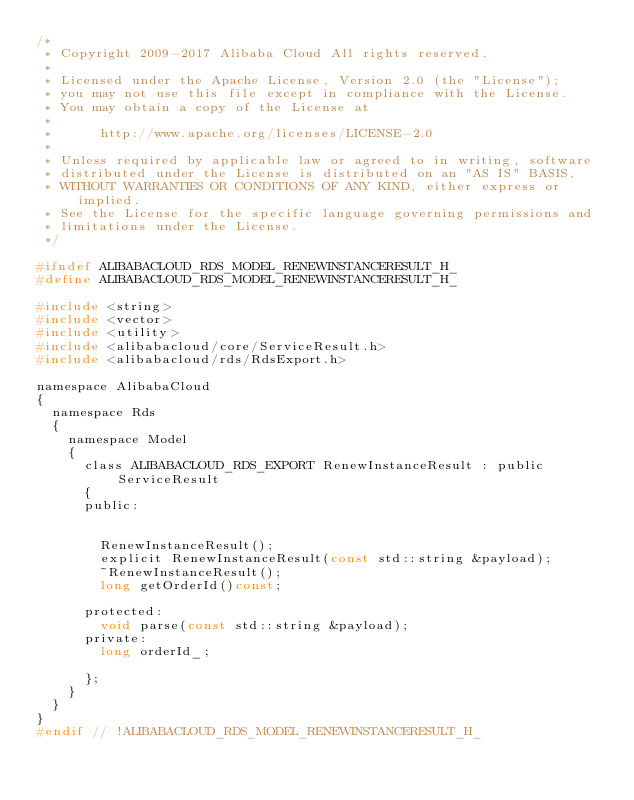<code> <loc_0><loc_0><loc_500><loc_500><_C_>/*
 * Copyright 2009-2017 Alibaba Cloud All rights reserved.
 * 
 * Licensed under the Apache License, Version 2.0 (the "License");
 * you may not use this file except in compliance with the License.
 * You may obtain a copy of the License at
 * 
 *      http://www.apache.org/licenses/LICENSE-2.0
 * 
 * Unless required by applicable law or agreed to in writing, software
 * distributed under the License is distributed on an "AS IS" BASIS,
 * WITHOUT WARRANTIES OR CONDITIONS OF ANY KIND, either express or implied.
 * See the License for the specific language governing permissions and
 * limitations under the License.
 */

#ifndef ALIBABACLOUD_RDS_MODEL_RENEWINSTANCERESULT_H_
#define ALIBABACLOUD_RDS_MODEL_RENEWINSTANCERESULT_H_

#include <string>
#include <vector>
#include <utility>
#include <alibabacloud/core/ServiceResult.h>
#include <alibabacloud/rds/RdsExport.h>

namespace AlibabaCloud
{
	namespace Rds
	{
		namespace Model
		{
			class ALIBABACLOUD_RDS_EXPORT RenewInstanceResult : public ServiceResult
			{
			public:


				RenewInstanceResult();
				explicit RenewInstanceResult(const std::string &payload);
				~RenewInstanceResult();
				long getOrderId()const;

			protected:
				void parse(const std::string &payload);
			private:
				long orderId_;

			};
		}
	}
}
#endif // !ALIBABACLOUD_RDS_MODEL_RENEWINSTANCERESULT_H_</code> 